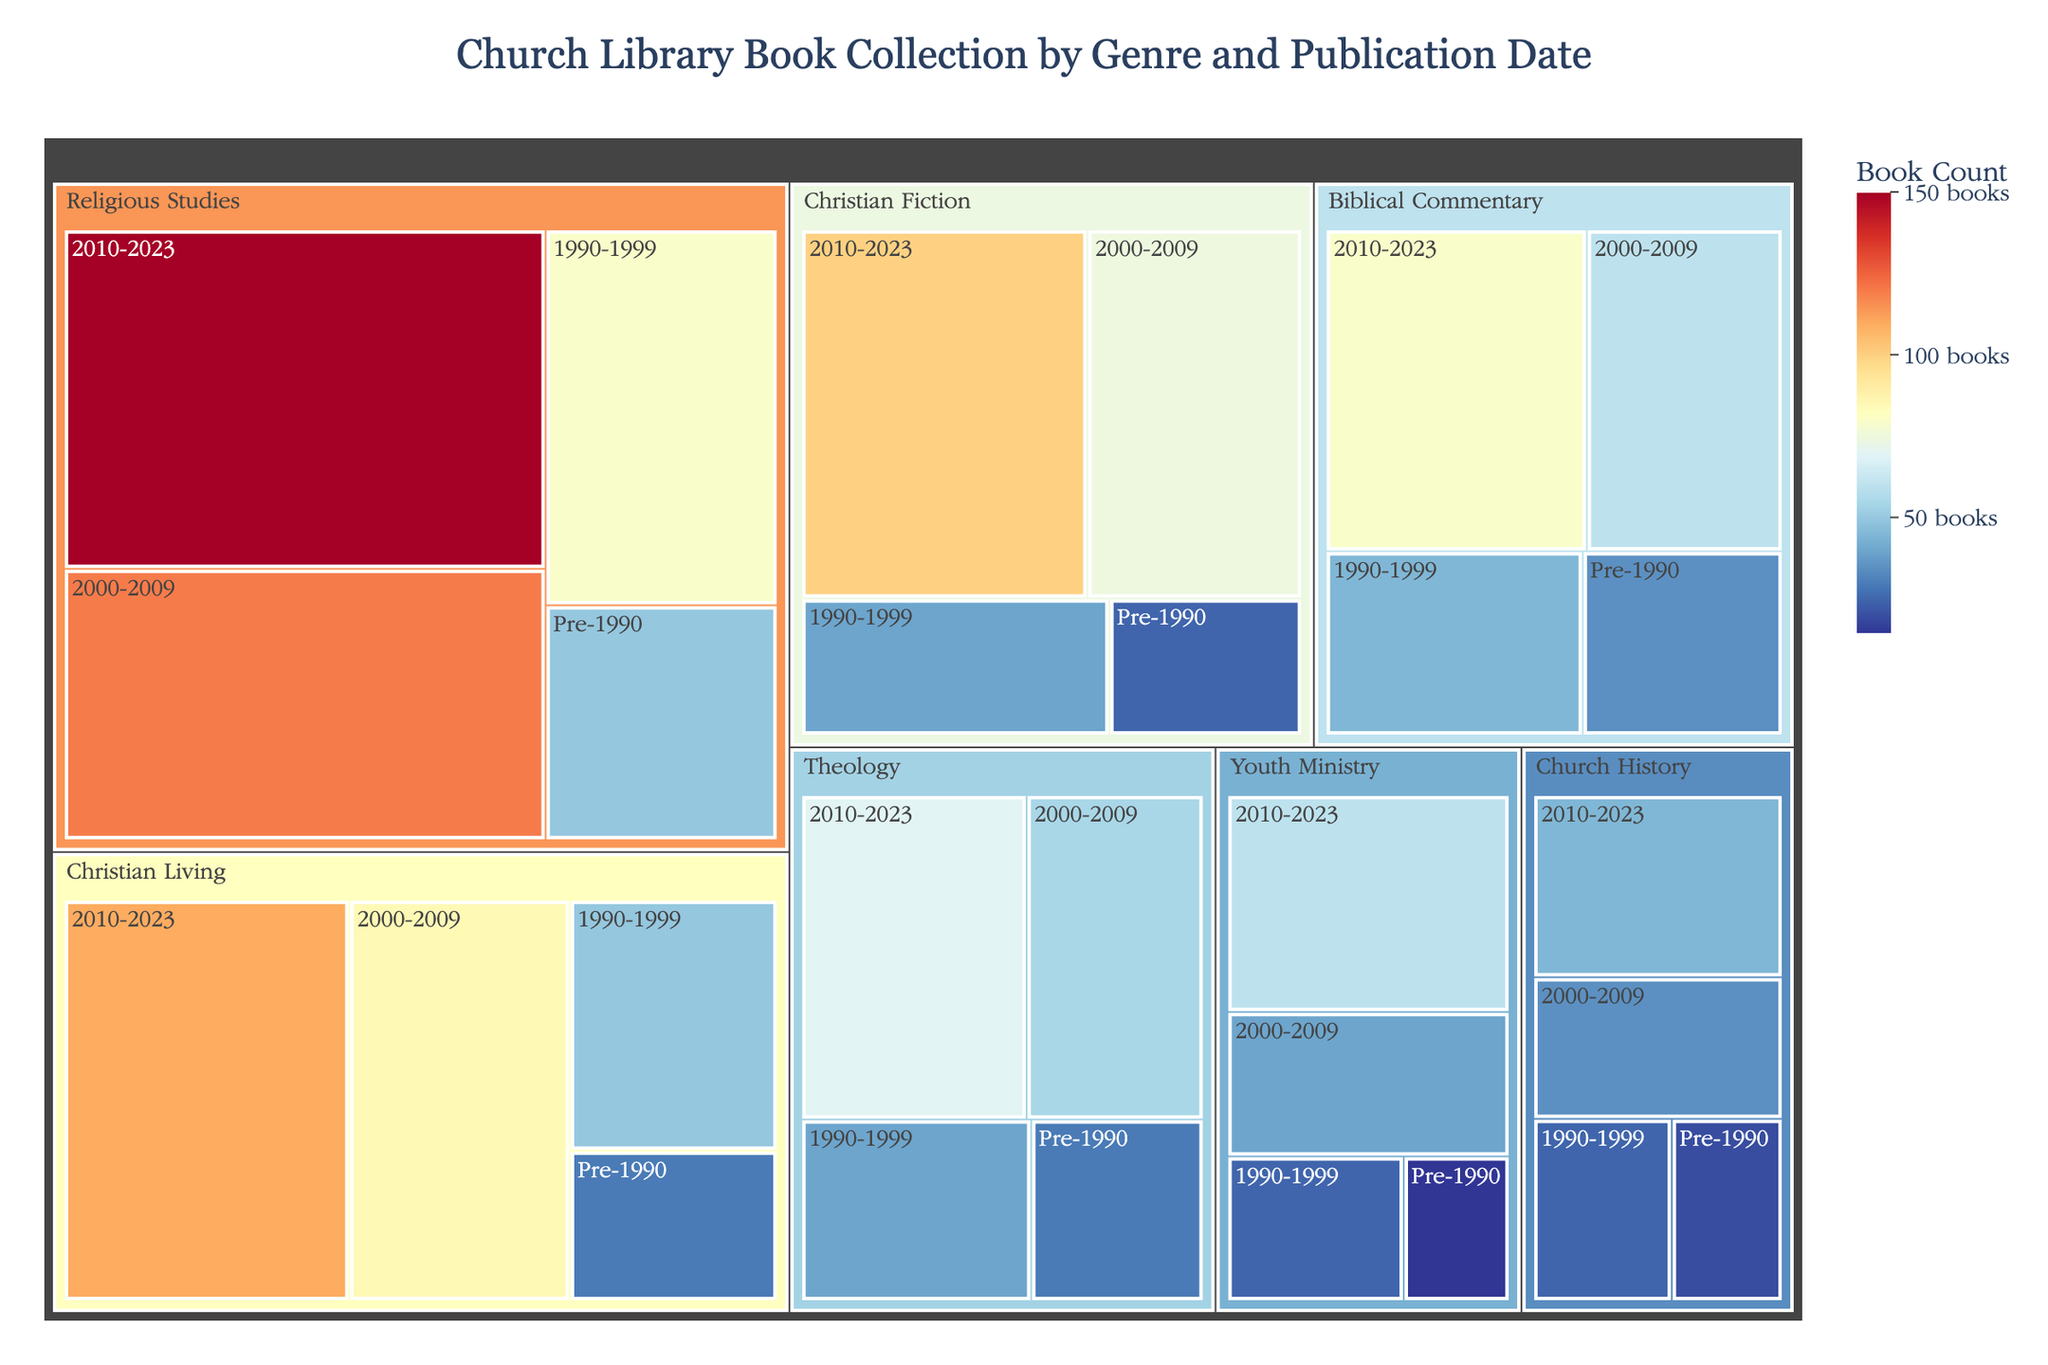what is the total count of Christian Fiction books in the library? To find the total count of Christian Fiction books, sum the counts from all publication periods: 100 (2010-2023) + 75 (2000-2009) + 40 (1990-1999) + 25 (Pre-1990) = 240
Answer: 240 which genre has the highest number of books published between 2010-2023? Look at the counts associated with each genre for the period 2010-2023. The highest number is 150 books, which corresponds to the Religious Studies genre.
Answer: Religious Studies how many books were published before 1990 in the Theology genre? The count for the Theology genre in the Pre-1990 period is 30 books.
Answer: 30 is the count of Christian Living books in 2010-2023 greater than the count of Biblical Commentary books in the same period? Compare the counts for these genres in the 2010-2023 period: Christian Living has 110 books, while Biblical Commentary has 80 books. Hence, Christian Living has a greater count.
Answer: Yes what is the total number of Church History books in the library? Sum the counts from all publication periods for the Church History genre: 45 (2010-2023) + 35 (2000-2009) + 25 (1990-1999) + 20 (Pre-1990) = 125
Answer: 125 how does the count of Youth Ministry books from 1990-1999 compare to the count from 2000-2009? Compare the counts for Youth Ministry: 25 books (1990-1999) and 40 books (2000-2009). The count from 2000-2009 is greater than from 1990-1999.
Answer: 2000-2009 is greater what is the overall count of books published between 2000 and 2009? Sum the counts from all genres for the period 2000-2009: 120 (Religious Studies) + 75 (Christian Fiction) + 60 (Biblical Commentary) + 55 (Theology) + 35 (Church History) + 85 (Christian Living) + 40 (Youth Ministry) = 470
Answer: 470 which genre has the smallest number of books published before 1990? Look at the counts from all genres for the Pre-1990 period: Religious Studies (50), Christian Fiction (25), Biblical Commentary (35), Theology (30), Church History (20), Christian Living (30), and Youth Ministry (15). The smallest count is for Youth Ministry with 15 books.
Answer: Youth Ministry 